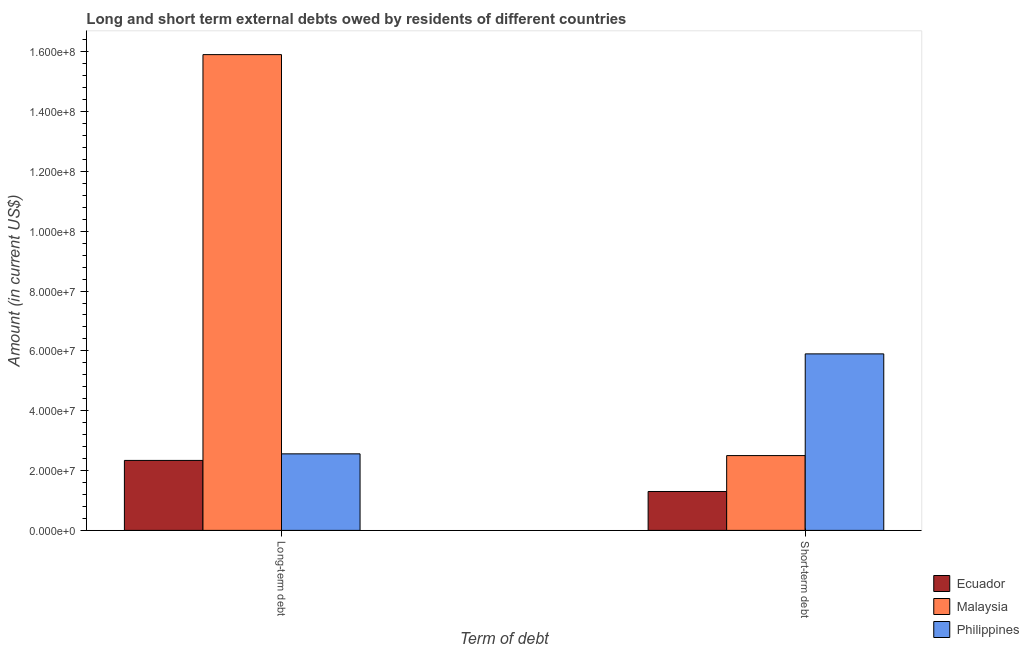How many groups of bars are there?
Your response must be concise. 2. How many bars are there on the 1st tick from the left?
Your response must be concise. 3. What is the label of the 2nd group of bars from the left?
Offer a terse response. Short-term debt. What is the long-term debts owed by residents in Ecuador?
Give a very brief answer. 2.34e+07. Across all countries, what is the maximum long-term debts owed by residents?
Make the answer very short. 1.59e+08. Across all countries, what is the minimum long-term debts owed by residents?
Your response must be concise. 2.34e+07. In which country was the long-term debts owed by residents maximum?
Your answer should be very brief. Malaysia. In which country was the short-term debts owed by residents minimum?
Provide a short and direct response. Ecuador. What is the total short-term debts owed by residents in the graph?
Provide a short and direct response. 9.70e+07. What is the difference between the long-term debts owed by residents in Philippines and that in Ecuador?
Ensure brevity in your answer.  2.19e+06. What is the difference between the long-term debts owed by residents in Ecuador and the short-term debts owed by residents in Philippines?
Your answer should be compact. -3.56e+07. What is the average long-term debts owed by residents per country?
Provide a short and direct response. 6.93e+07. What is the difference between the short-term debts owed by residents and long-term debts owed by residents in Philippines?
Your answer should be very brief. 3.34e+07. In how many countries, is the short-term debts owed by residents greater than 104000000 US$?
Offer a terse response. 0. What is the ratio of the short-term debts owed by residents in Philippines to that in Malaysia?
Keep it short and to the point. 2.36. What does the 2nd bar from the left in Short-term debt represents?
Offer a terse response. Malaysia. What does the 2nd bar from the right in Long-term debt represents?
Provide a succinct answer. Malaysia. How many bars are there?
Your answer should be very brief. 6. What is the difference between two consecutive major ticks on the Y-axis?
Provide a short and direct response. 2.00e+07. Where does the legend appear in the graph?
Provide a short and direct response. Bottom right. How are the legend labels stacked?
Offer a very short reply. Vertical. What is the title of the graph?
Offer a very short reply. Long and short term external debts owed by residents of different countries. Does "Bosnia and Herzegovina" appear as one of the legend labels in the graph?
Keep it short and to the point. No. What is the label or title of the X-axis?
Your response must be concise. Term of debt. What is the Amount (in current US$) in Ecuador in Long-term debt?
Provide a short and direct response. 2.34e+07. What is the Amount (in current US$) of Malaysia in Long-term debt?
Your answer should be very brief. 1.59e+08. What is the Amount (in current US$) in Philippines in Long-term debt?
Give a very brief answer. 2.56e+07. What is the Amount (in current US$) in Ecuador in Short-term debt?
Provide a short and direct response. 1.30e+07. What is the Amount (in current US$) in Malaysia in Short-term debt?
Your response must be concise. 2.50e+07. What is the Amount (in current US$) of Philippines in Short-term debt?
Provide a short and direct response. 5.90e+07. Across all Term of debt, what is the maximum Amount (in current US$) of Ecuador?
Give a very brief answer. 2.34e+07. Across all Term of debt, what is the maximum Amount (in current US$) of Malaysia?
Offer a very short reply. 1.59e+08. Across all Term of debt, what is the maximum Amount (in current US$) in Philippines?
Provide a short and direct response. 5.90e+07. Across all Term of debt, what is the minimum Amount (in current US$) in Ecuador?
Give a very brief answer. 1.30e+07. Across all Term of debt, what is the minimum Amount (in current US$) of Malaysia?
Offer a terse response. 2.50e+07. Across all Term of debt, what is the minimum Amount (in current US$) of Philippines?
Keep it short and to the point. 2.56e+07. What is the total Amount (in current US$) of Ecuador in the graph?
Ensure brevity in your answer.  3.64e+07. What is the total Amount (in current US$) in Malaysia in the graph?
Provide a short and direct response. 1.84e+08. What is the total Amount (in current US$) in Philippines in the graph?
Keep it short and to the point. 8.46e+07. What is the difference between the Amount (in current US$) in Ecuador in Long-term debt and that in Short-term debt?
Give a very brief answer. 1.04e+07. What is the difference between the Amount (in current US$) in Malaysia in Long-term debt and that in Short-term debt?
Provide a succinct answer. 1.34e+08. What is the difference between the Amount (in current US$) in Philippines in Long-term debt and that in Short-term debt?
Provide a succinct answer. -3.34e+07. What is the difference between the Amount (in current US$) in Ecuador in Long-term debt and the Amount (in current US$) in Malaysia in Short-term debt?
Your response must be concise. -1.61e+06. What is the difference between the Amount (in current US$) of Ecuador in Long-term debt and the Amount (in current US$) of Philippines in Short-term debt?
Give a very brief answer. -3.56e+07. What is the difference between the Amount (in current US$) in Malaysia in Long-term debt and the Amount (in current US$) in Philippines in Short-term debt?
Your answer should be compact. 1.00e+08. What is the average Amount (in current US$) of Ecuador per Term of debt?
Make the answer very short. 1.82e+07. What is the average Amount (in current US$) of Malaysia per Term of debt?
Provide a succinct answer. 9.20e+07. What is the average Amount (in current US$) in Philippines per Term of debt?
Your answer should be compact. 4.23e+07. What is the difference between the Amount (in current US$) of Ecuador and Amount (in current US$) of Malaysia in Long-term debt?
Give a very brief answer. -1.36e+08. What is the difference between the Amount (in current US$) in Ecuador and Amount (in current US$) in Philippines in Long-term debt?
Your response must be concise. -2.19e+06. What is the difference between the Amount (in current US$) in Malaysia and Amount (in current US$) in Philippines in Long-term debt?
Offer a very short reply. 1.33e+08. What is the difference between the Amount (in current US$) in Ecuador and Amount (in current US$) in Malaysia in Short-term debt?
Ensure brevity in your answer.  -1.20e+07. What is the difference between the Amount (in current US$) in Ecuador and Amount (in current US$) in Philippines in Short-term debt?
Your answer should be compact. -4.60e+07. What is the difference between the Amount (in current US$) in Malaysia and Amount (in current US$) in Philippines in Short-term debt?
Provide a succinct answer. -3.40e+07. What is the ratio of the Amount (in current US$) in Ecuador in Long-term debt to that in Short-term debt?
Offer a very short reply. 1.8. What is the ratio of the Amount (in current US$) in Malaysia in Long-term debt to that in Short-term debt?
Your answer should be very brief. 6.36. What is the ratio of the Amount (in current US$) in Philippines in Long-term debt to that in Short-term debt?
Offer a terse response. 0.43. What is the difference between the highest and the second highest Amount (in current US$) of Ecuador?
Make the answer very short. 1.04e+07. What is the difference between the highest and the second highest Amount (in current US$) in Malaysia?
Your answer should be compact. 1.34e+08. What is the difference between the highest and the second highest Amount (in current US$) in Philippines?
Offer a terse response. 3.34e+07. What is the difference between the highest and the lowest Amount (in current US$) of Ecuador?
Your answer should be very brief. 1.04e+07. What is the difference between the highest and the lowest Amount (in current US$) of Malaysia?
Offer a very short reply. 1.34e+08. What is the difference between the highest and the lowest Amount (in current US$) of Philippines?
Make the answer very short. 3.34e+07. 